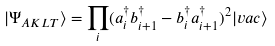Convert formula to latex. <formula><loc_0><loc_0><loc_500><loc_500>| \Psi _ { A K L T } \rangle = \prod _ { i } ( a _ { i } ^ { \dag } b _ { i + 1 } ^ { \dag } - b _ { i } ^ { \dag } a _ { i + 1 } ^ { \dag } ) ^ { 2 } | v a c \rangle</formula> 